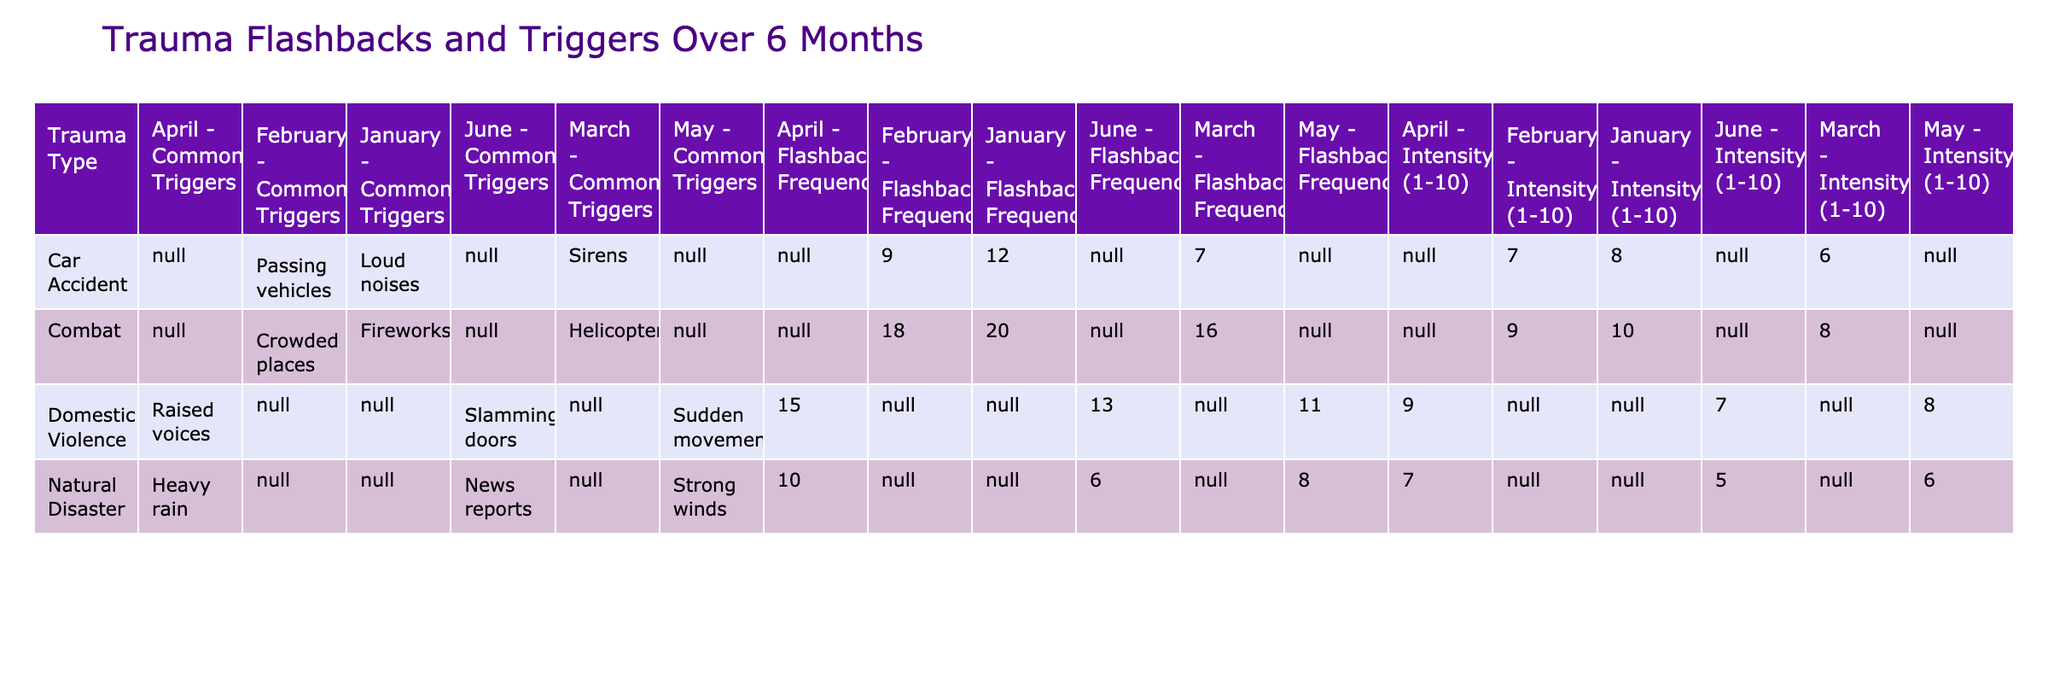What was the flashback frequency for Domestic Violence in March? The table shows that for Domestic Violence in March, the flashback frequency is listed as 11.
Answer: 11 What common trigger is associated with flashbacks for Combat in February? The table indicates that for Combat in February, the common trigger is "Crowded places."
Answer: Crowded places What was the highest intensity rating recorded for any trauma type over the 6 months? By reviewing the intensity ratings, the highest recorded intensity is 10, observed for Combat in January.
Answer: 10 How many times did flashbacks occur for Car Accident triggers from January to March combined? The flashback frequencies for Car Accident from January to March are 12, 9, and 7, respectively. Summing these gives 12 + 9 + 7 = 28.
Answer: 28 What was the average flashback frequency for Domestic Violence across the 6 months? The frequencies are 15, 11, and 13. To find the average, sum these values (15 + 11 + 13 = 39) and divide by the number of months (3), giving an average of 39 / 3 = 13.
Answer: 13 Was there a decrease in flashback frequency for Natural Disaster from January to June? The data shows Natural Disaster frequencies are 10, 8, and 6 for those months, indicating a consistent decrease in frequency.
Answer: Yes Which month had the lowest flashback frequency for Combat? The table reveals that Combat had flashback frequencies of 20, 18, and 16, with the lowest being 16 in March.
Answer: March If we consider the highest intensity ratings per trauma type, which trauma type had the highest recorded intensity? The highest intensity rating recorded is 10 for Combat in January, which is compared against all other trauma types in the table.
Answer: Combat How many total triggers are listed for the Domestic Violence trauma type? The table lists the common triggers for Domestic Violence as “Raised voices," "Sudden movements," and "Slamming doors," indicating a total of 3 triggers.
Answer: 3 What is the difference in flashback frequency for Car Accident between January and March? The table shows the flashback frequency for Car Accident as 12 in January and 7 in March. The difference is 12 - 7 = 5.
Answer: 5 